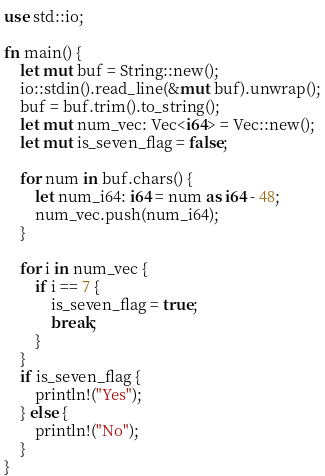Convert code to text. <code><loc_0><loc_0><loc_500><loc_500><_Rust_>use std::io;

fn main() {
    let mut buf = String::new();
    io::stdin().read_line(&mut buf).unwrap();
    buf = buf.trim().to_string();
    let mut num_vec: Vec<i64> = Vec::new();
    let mut is_seven_flag = false;

    for num in buf.chars() {
        let num_i64: i64 = num as i64 - 48;
        num_vec.push(num_i64);
    }

    for i in num_vec {
        if i == 7 {
            is_seven_flag = true;
            break;
        }
    }
    if is_seven_flag {
        println!("Yes");
    } else {
        println!("No");
    }
}
</code> 